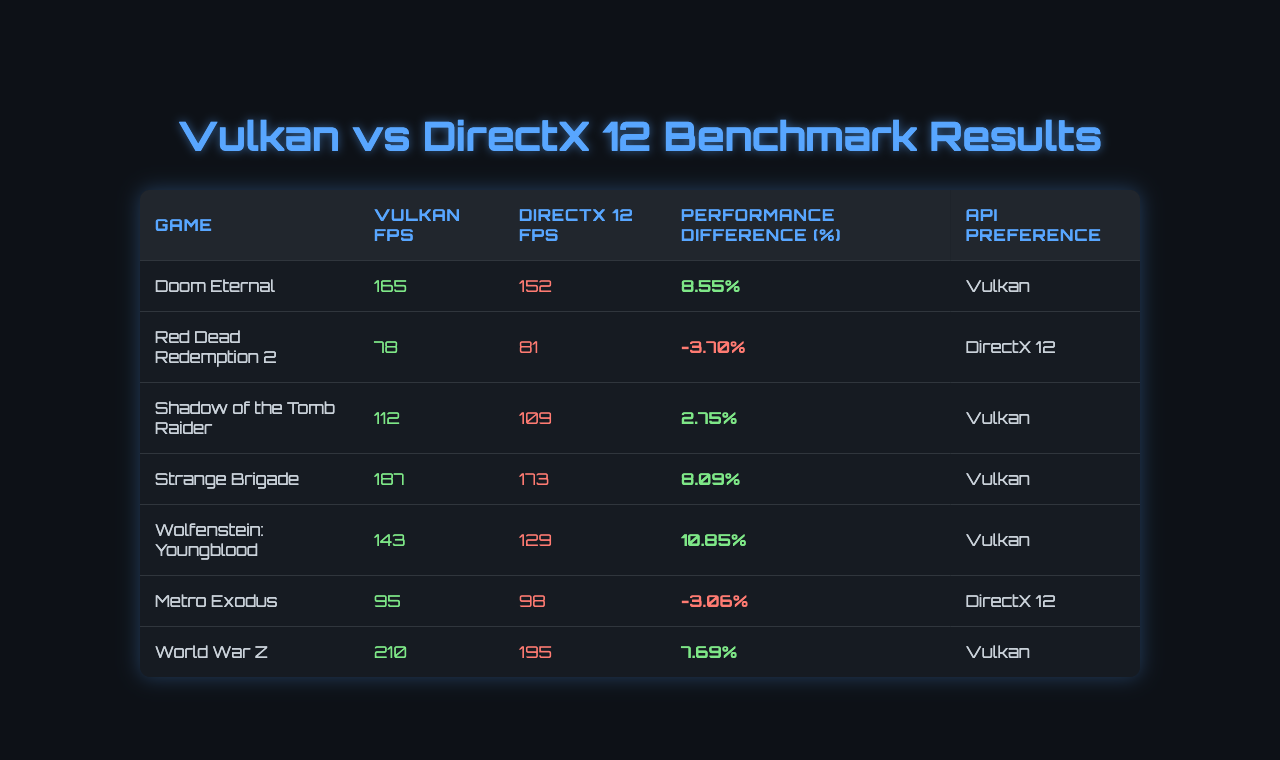What is the FPS score for Doom Eternal using Vulkan? The table lists the FPS score for Doom Eternal under the Vulkan column, which is 165.
Answer: 165 What is the FPS score for Red Dead Redemption 2 using DirectX 12? The table shows that the FPS score for Red Dead Redemption 2 with DirectX 12 is 81.
Answer: 81 Which game shows a performance difference in favor of Vulkan? By checking the 'Performance Difference (%)' column, Doom Eternal, Shadow of the Tomb Raider, Strange Brigade, and Wolfenstein: Youngblood have positive percentages, indicating Vulkan performs better.
Answer: Doom Eternal, Shadow of the Tomb Raider, Strange Brigade, Wolfenstein: Youngblood What is the percentage performance difference for Metro Exodus? The table indicates that the performance difference for Metro Exodus is -3.06%, which means DirectX 12 performs better than Vulkan for this game.
Answer: -3.06% What is the average FPS for games using Vulkan? To find the average FPS for Vulkan, add the FPS scores: (165 + 78 + 112 + 187 + 143 + 95 + 210) = 990. Since there are 7 games, the average is 990 / 7 = 141.43.
Answer: 141.43 Is there any game where DirectX 12 performs significantly better than Vulkan? Yes, in the case of Red Dead Redemption 2 and Metro Exodus, DirectX 12 has higher FPS than Vulkan, making it a preferable option in those instances.
Answer: Yes What is the total number of games listed in the table that have Vulkan as the preferred API? By looking at the 'API Preference' column, there are 5 games where Vulkan is preferred.
Answer: 5 Which game has the highest FPS using Vulkan? The table shows that World War Z has the highest FPS under the Vulkan column, which is 210.
Answer: World War Z What percentage difference represents the best performance improvement for Vulkan? Among all games, Wolfenstein: Youngblood shows the highest performance difference for Vulkan at 10.85%.
Answer: 10.85% What is the performance difference percentage for the game with the lowest FPS using Vulkan? The game with the lowest FPS using Vulkan is Red Dead Redemption 2, which has a performance difference of -3.70%.
Answer: -3.70% 